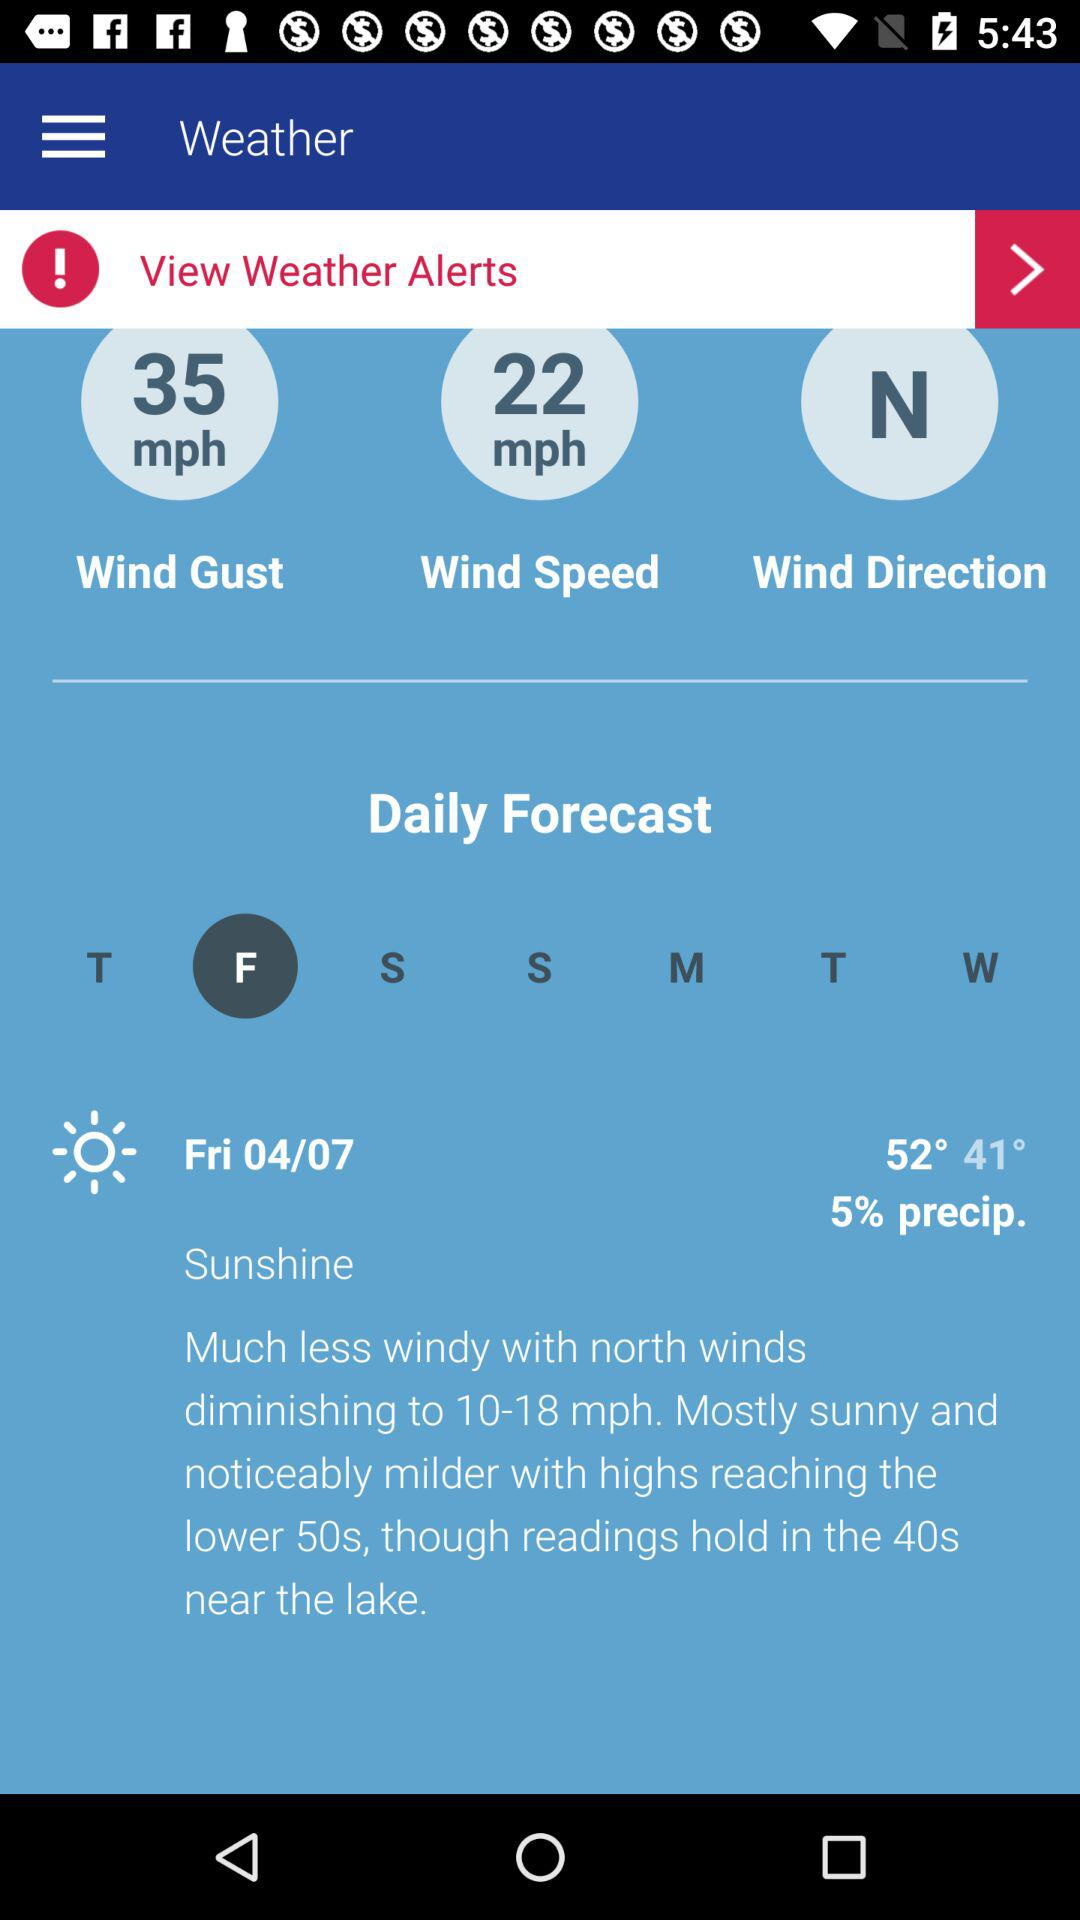What is the mentioned date? The mentioned date is Friday, April 4. 